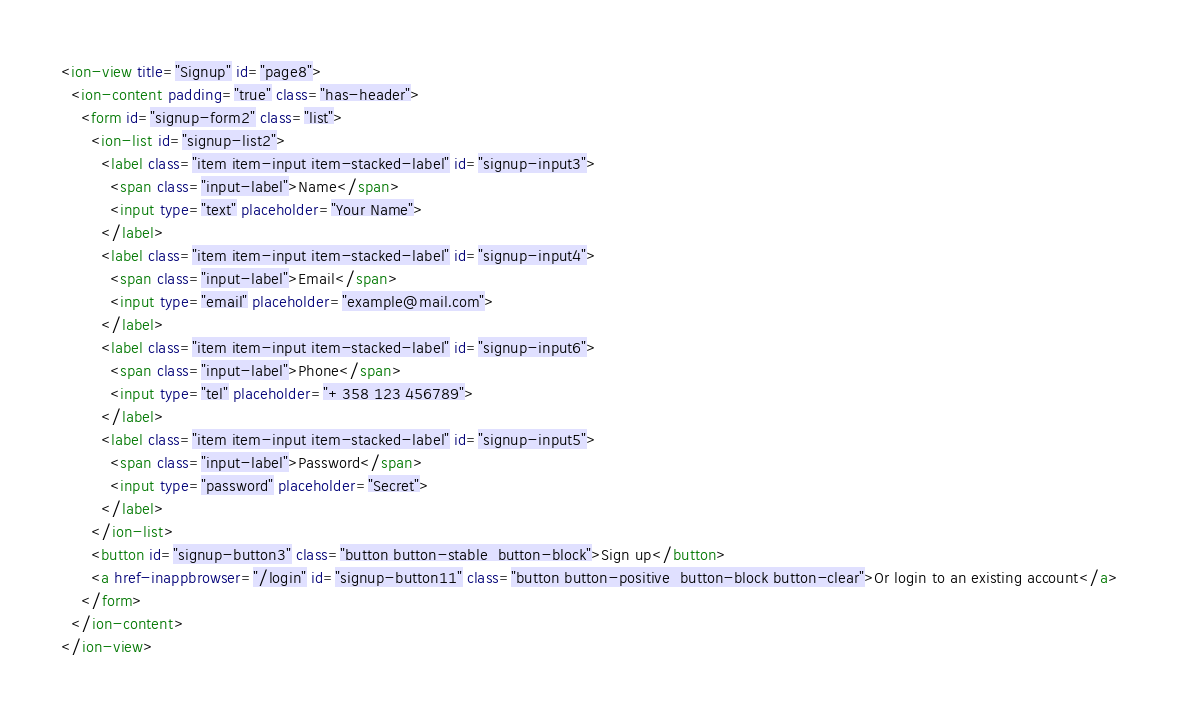<code> <loc_0><loc_0><loc_500><loc_500><_HTML_><ion-view title="Signup" id="page8">
  <ion-content padding="true" class="has-header">
    <form id="signup-form2" class="list">
      <ion-list id="signup-list2">
        <label class="item item-input item-stacked-label" id="signup-input3">
          <span class="input-label">Name</span>
          <input type="text" placeholder="Your Name">
        </label>
        <label class="item item-input item-stacked-label" id="signup-input4">
          <span class="input-label">Email</span>
          <input type="email" placeholder="example@mail.com">
        </label>
        <label class="item item-input item-stacked-label" id="signup-input6">
          <span class="input-label">Phone</span>
          <input type="tel" placeholder="+358 123 456789">
        </label>
        <label class="item item-input item-stacked-label" id="signup-input5">
          <span class="input-label">Password</span>
          <input type="password" placeholder="Secret">
        </label>
      </ion-list>
      <button id="signup-button3" class="button button-stable  button-block">Sign up</button>
      <a href-inappbrowser="/login" id="signup-button11" class="button button-positive  button-block button-clear">Or login to an existing account</a>
    </form>
  </ion-content>
</ion-view></code> 